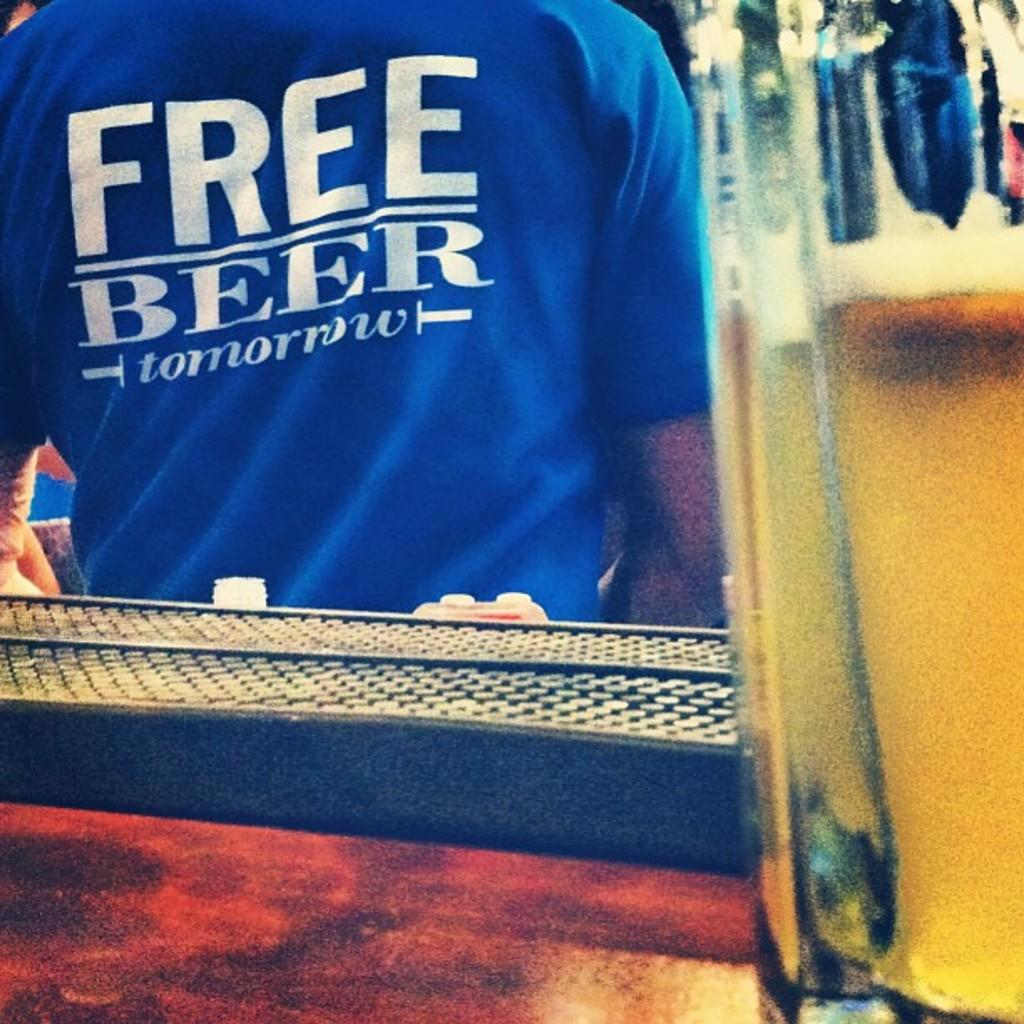<image>
Give a short and clear explanation of the subsequent image. The back of a blue t-shirt says "free beer tomorrow." 